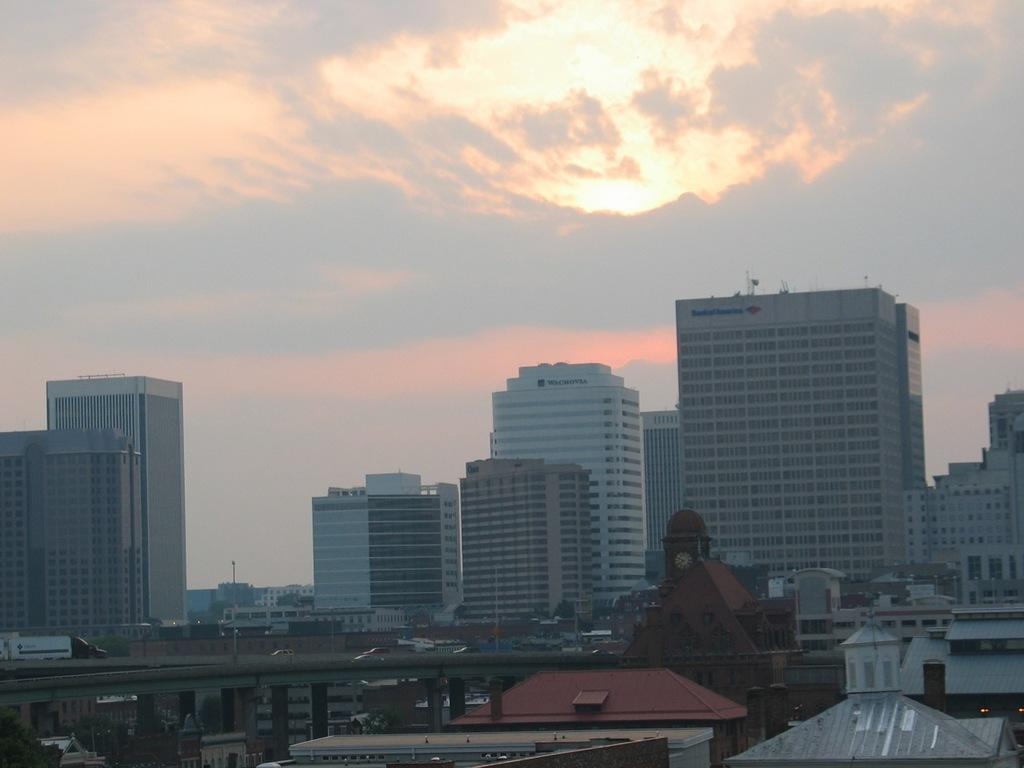What is the main structure in the center of the image? There is a bridge in the center of the image. What is happening on the bridge? Vehicles are present on the bridge. What can be seen in the distance behind the bridge? There are many buildings in the background of the image. What is visible at the top of the image? The sky is visible at the top of the image. What type of beetle can be seen crawling on the shirt of a person in the image? There is no person or shirt present in the image, and therefore no beetle can be seen crawling on it. 